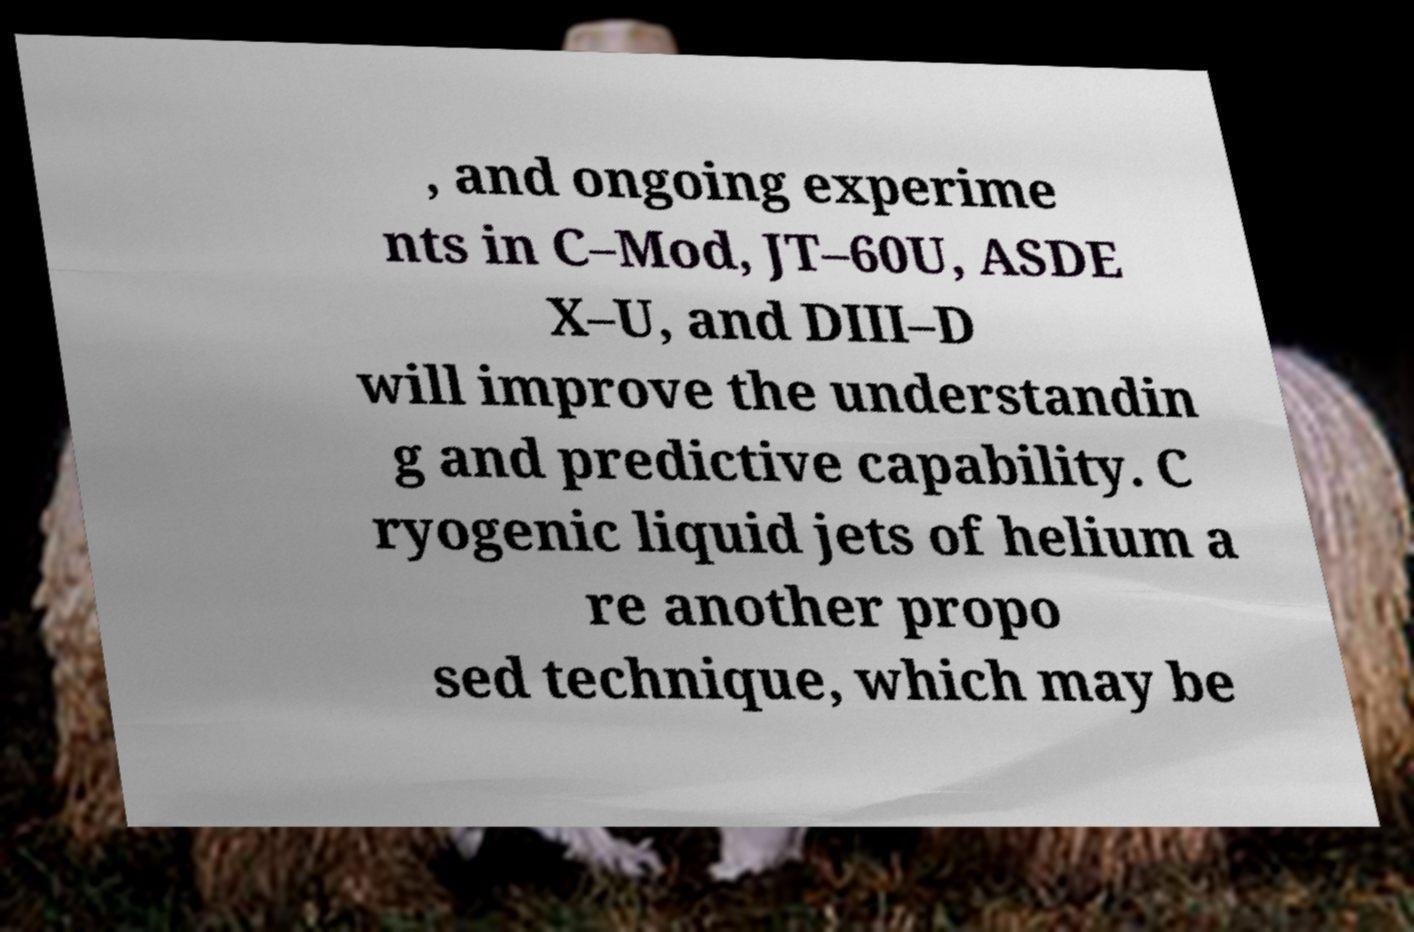Please identify and transcribe the text found in this image. , and ongoing experime nts in C–Mod, JT–60U, ASDE X–U, and DIII–D will improve the understandin g and predictive capability. C ryogenic liquid jets of helium a re another propo sed technique, which may be 